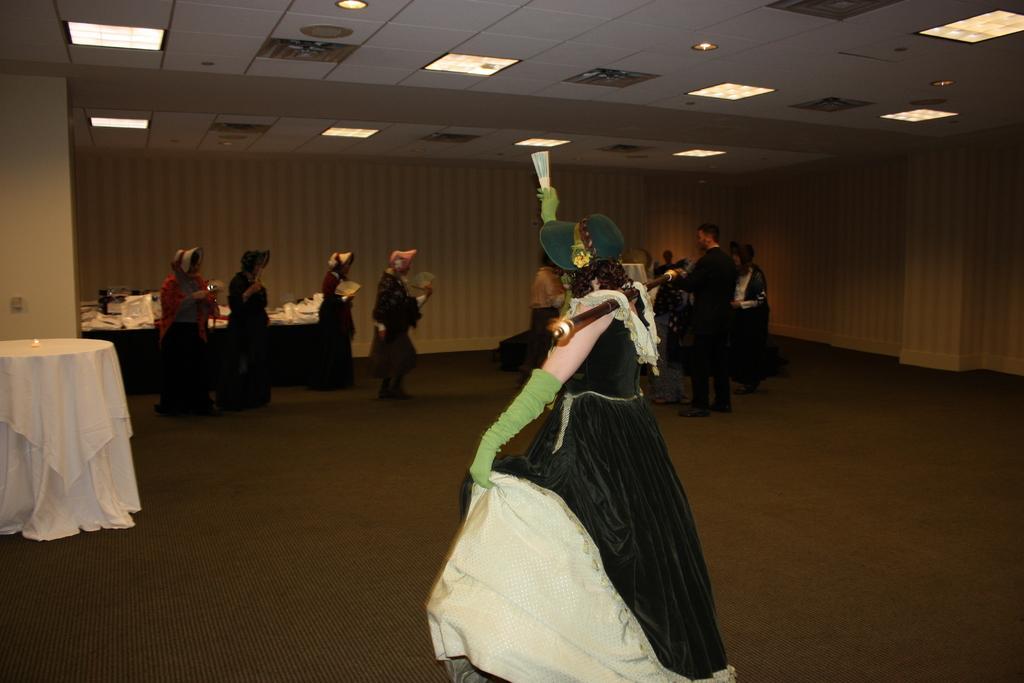Could you give a brief overview of what you see in this image? In the center of the picture there is a woman dancing. On the left there is a table. At the top there are lights to the ceiling. In the background there are people tables and other objects. 